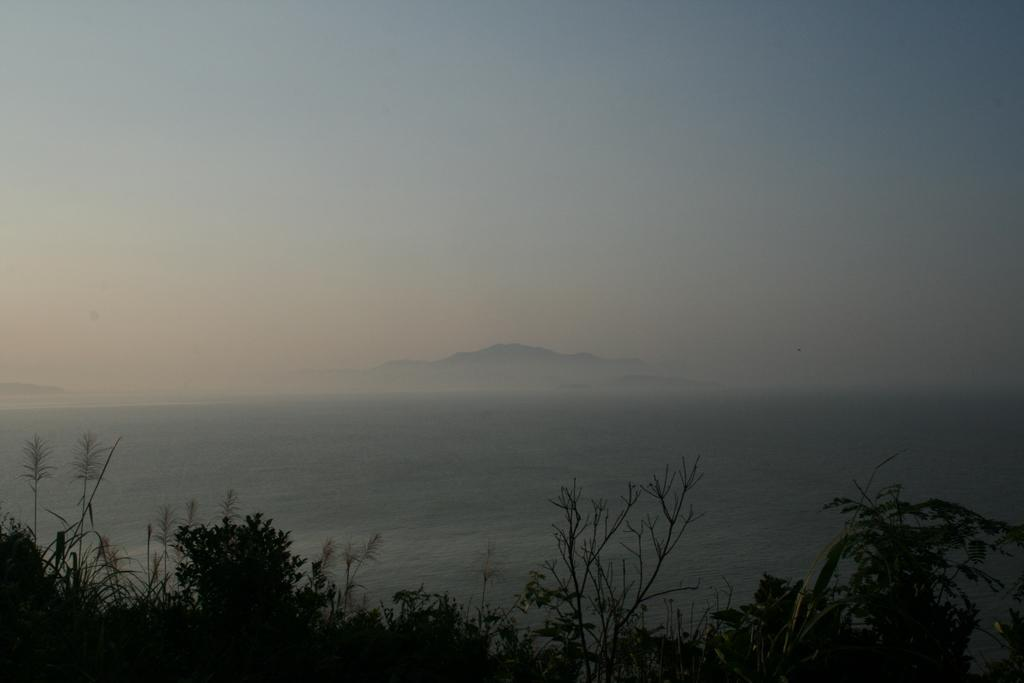What can be seen at the top of the image? The sky is visible towards the top of the image. What type of natural landform is present in the image? There are mountains in the image. What body of water is visible in the image? There is the sea in the image. What type of vegetation is present towards the bottom of the image? Plants are present towards the bottom of the image. Can you tell me how many icicles are hanging from the mountains in the image? There are no icicles present in the image; it features mountains, sea, sky, and plants. What type of writing can be seen on the plants in the image? There is no writing present on the plants in the image; only the plants themselves are visible. 